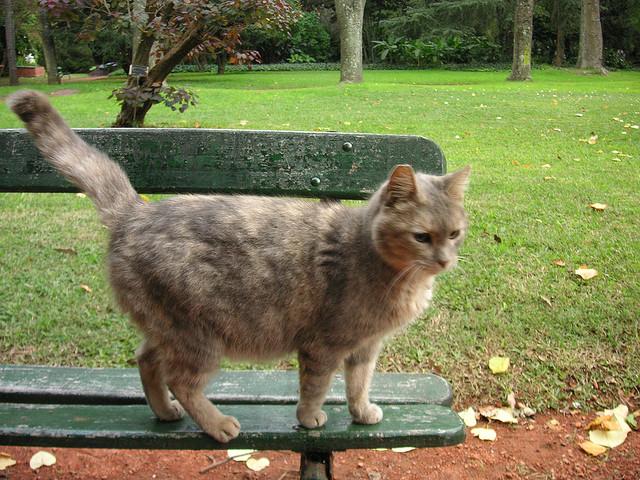What pattern is the cat's coat?
Concise answer only. Calico. Is this a park?
Short answer required. Yes. Where is the cat standing?
Answer briefly. Bench. Do you see human feet?
Give a very brief answer. No. 